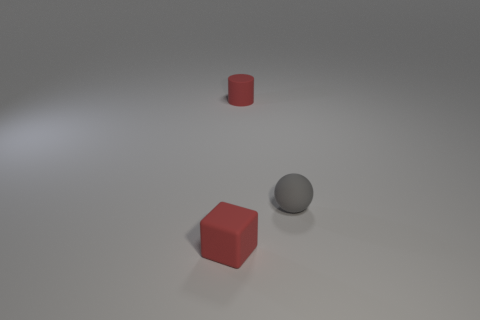Add 3 small rubber balls. How many objects exist? 6 Subtract all blocks. How many objects are left? 2 Subtract 0 green cylinders. How many objects are left? 3 Subtract all tiny spheres. Subtract all tiny red blocks. How many objects are left? 1 Add 2 small cylinders. How many small cylinders are left? 3 Add 1 tiny brown matte things. How many tiny brown matte things exist? 1 